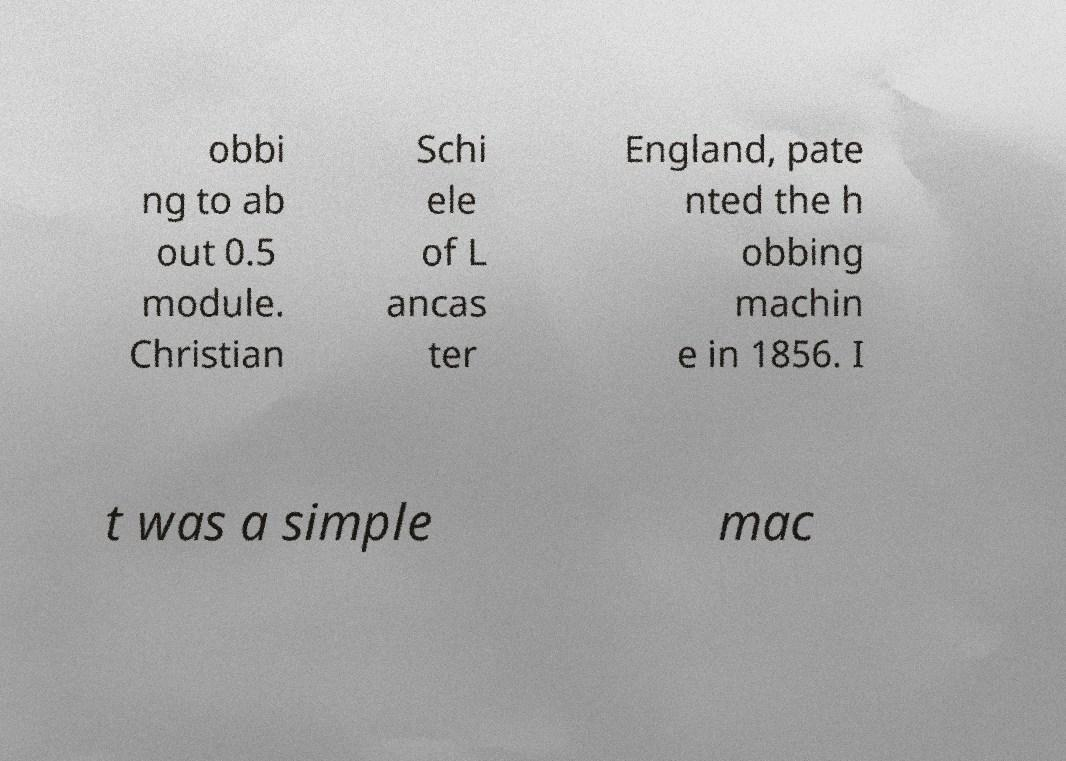Could you extract and type out the text from this image? obbi ng to ab out 0.5 module. Christian Schi ele of L ancas ter England, pate nted the h obbing machin e in 1856. I t was a simple mac 